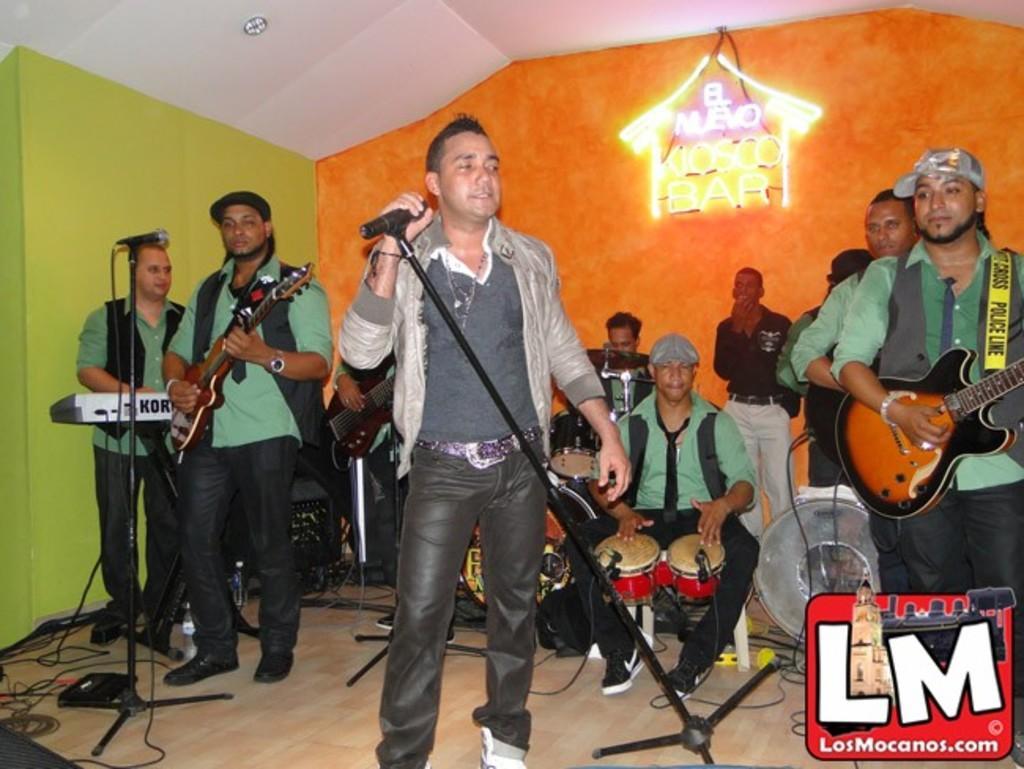In one or two sentences, can you explain what this image depicts? In this image, group of peoples are playing a musical instruments. And the center person is holding microphone in his hand. Here we can see stand, wires on the floor. Back side, we can see orange color. On left side, we can see green color wall and white color roof. her we can see right side person is wearing a cap on his head. 